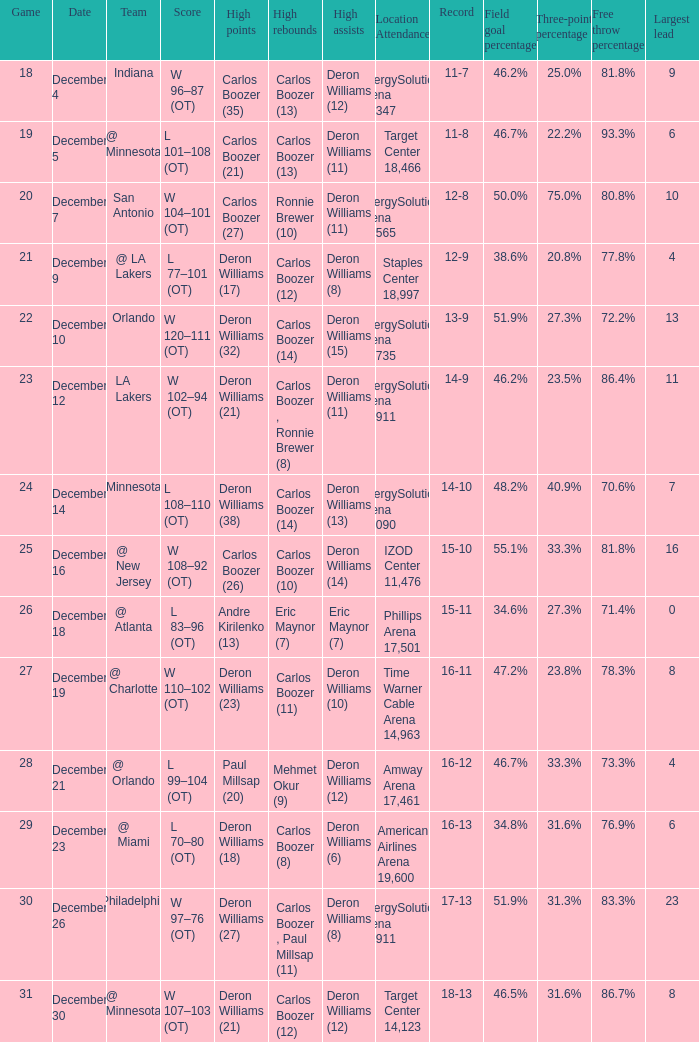When was the game in which Deron Williams (13) did the high assists played? December 14. 